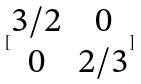<formula> <loc_0><loc_0><loc_500><loc_500>[ \begin{matrix} 3 / 2 & 0 \\ 0 & 2 / 3 \end{matrix} ]</formula> 